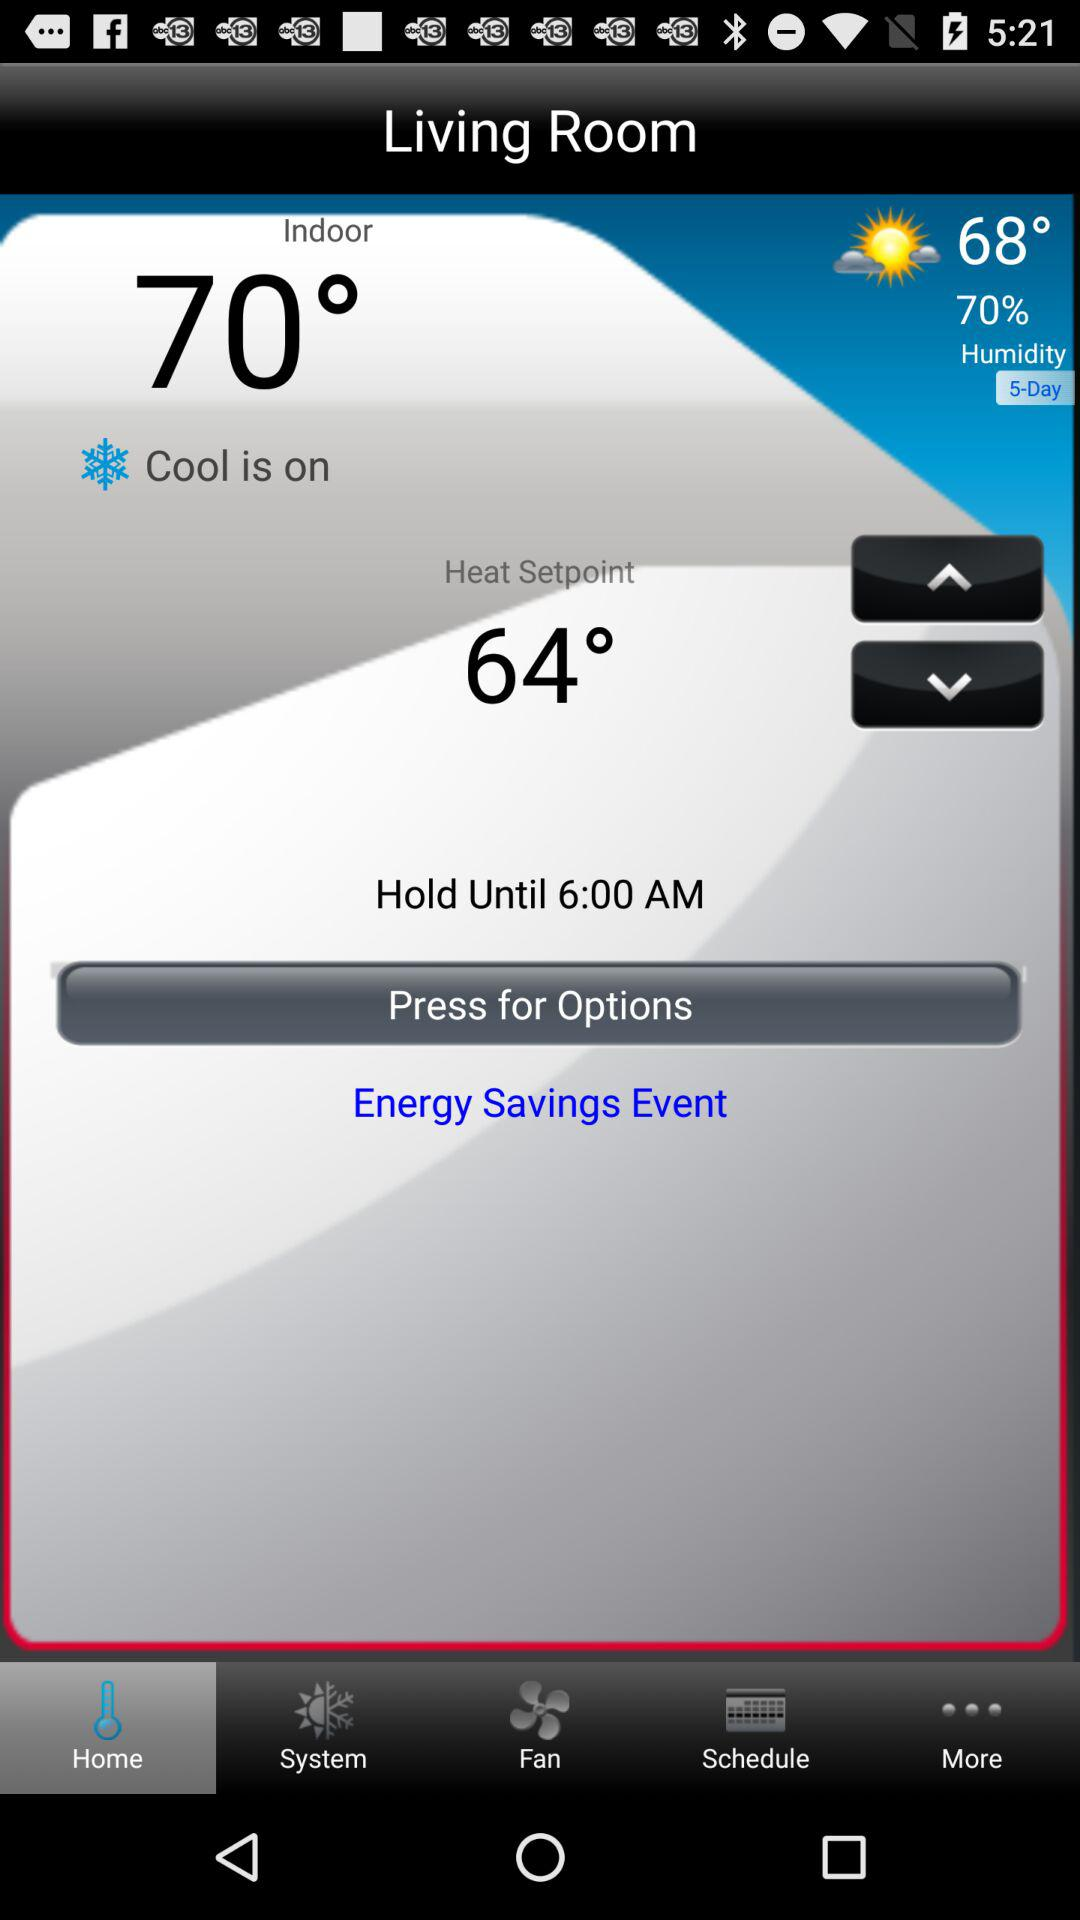What is the humidity level?
Answer the question using a single word or phrase. 70% 